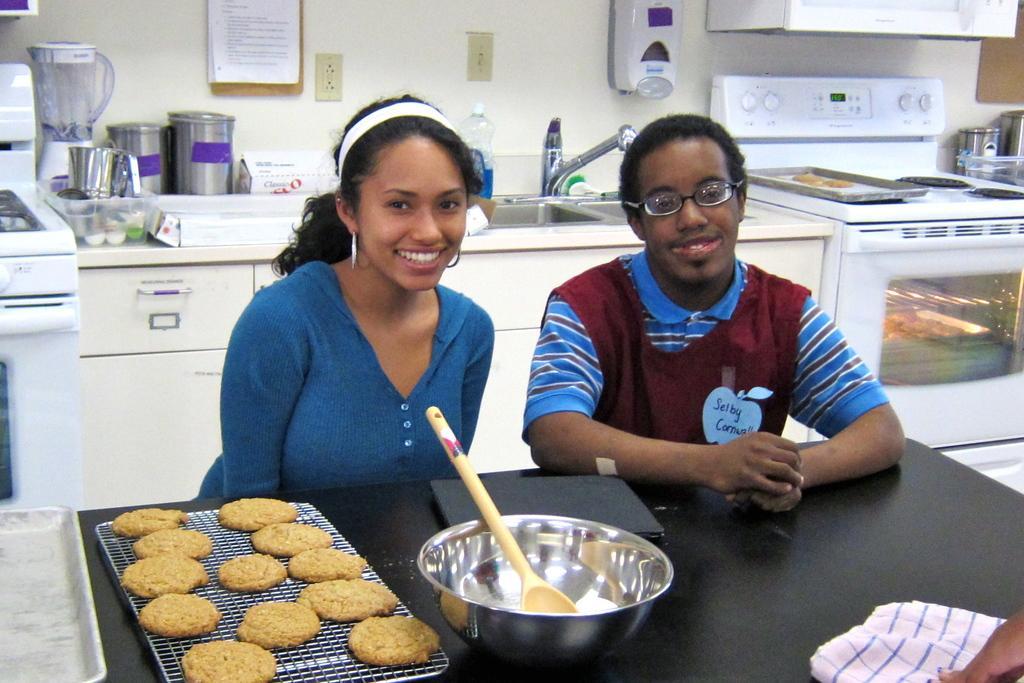Describe this image in one or two sentences. There are two persons sitting,in front of these persons we can see food on grills,tray,bowl,spoon and objects on able. Background we can see sink with tap, tray on stove,under the stove we can see oven and we can see jars and some objects on surface and wall. 